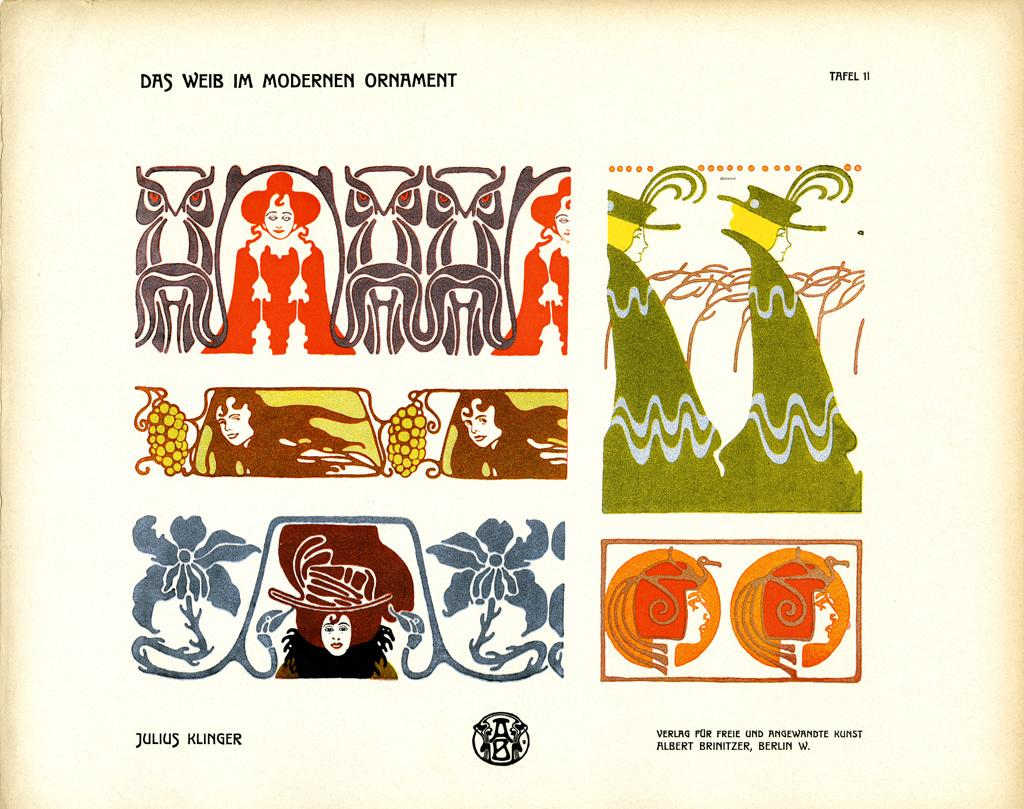What is present in the image that contains visual information? There is a poster in the image. What types of content can be found on the poster? The poster contains images and text. How many babies are depicted on the poster in the image? There is no information about babies on the poster in the image. What type of car is shown on the poster in the image? There is no car present on the poster in the image. 